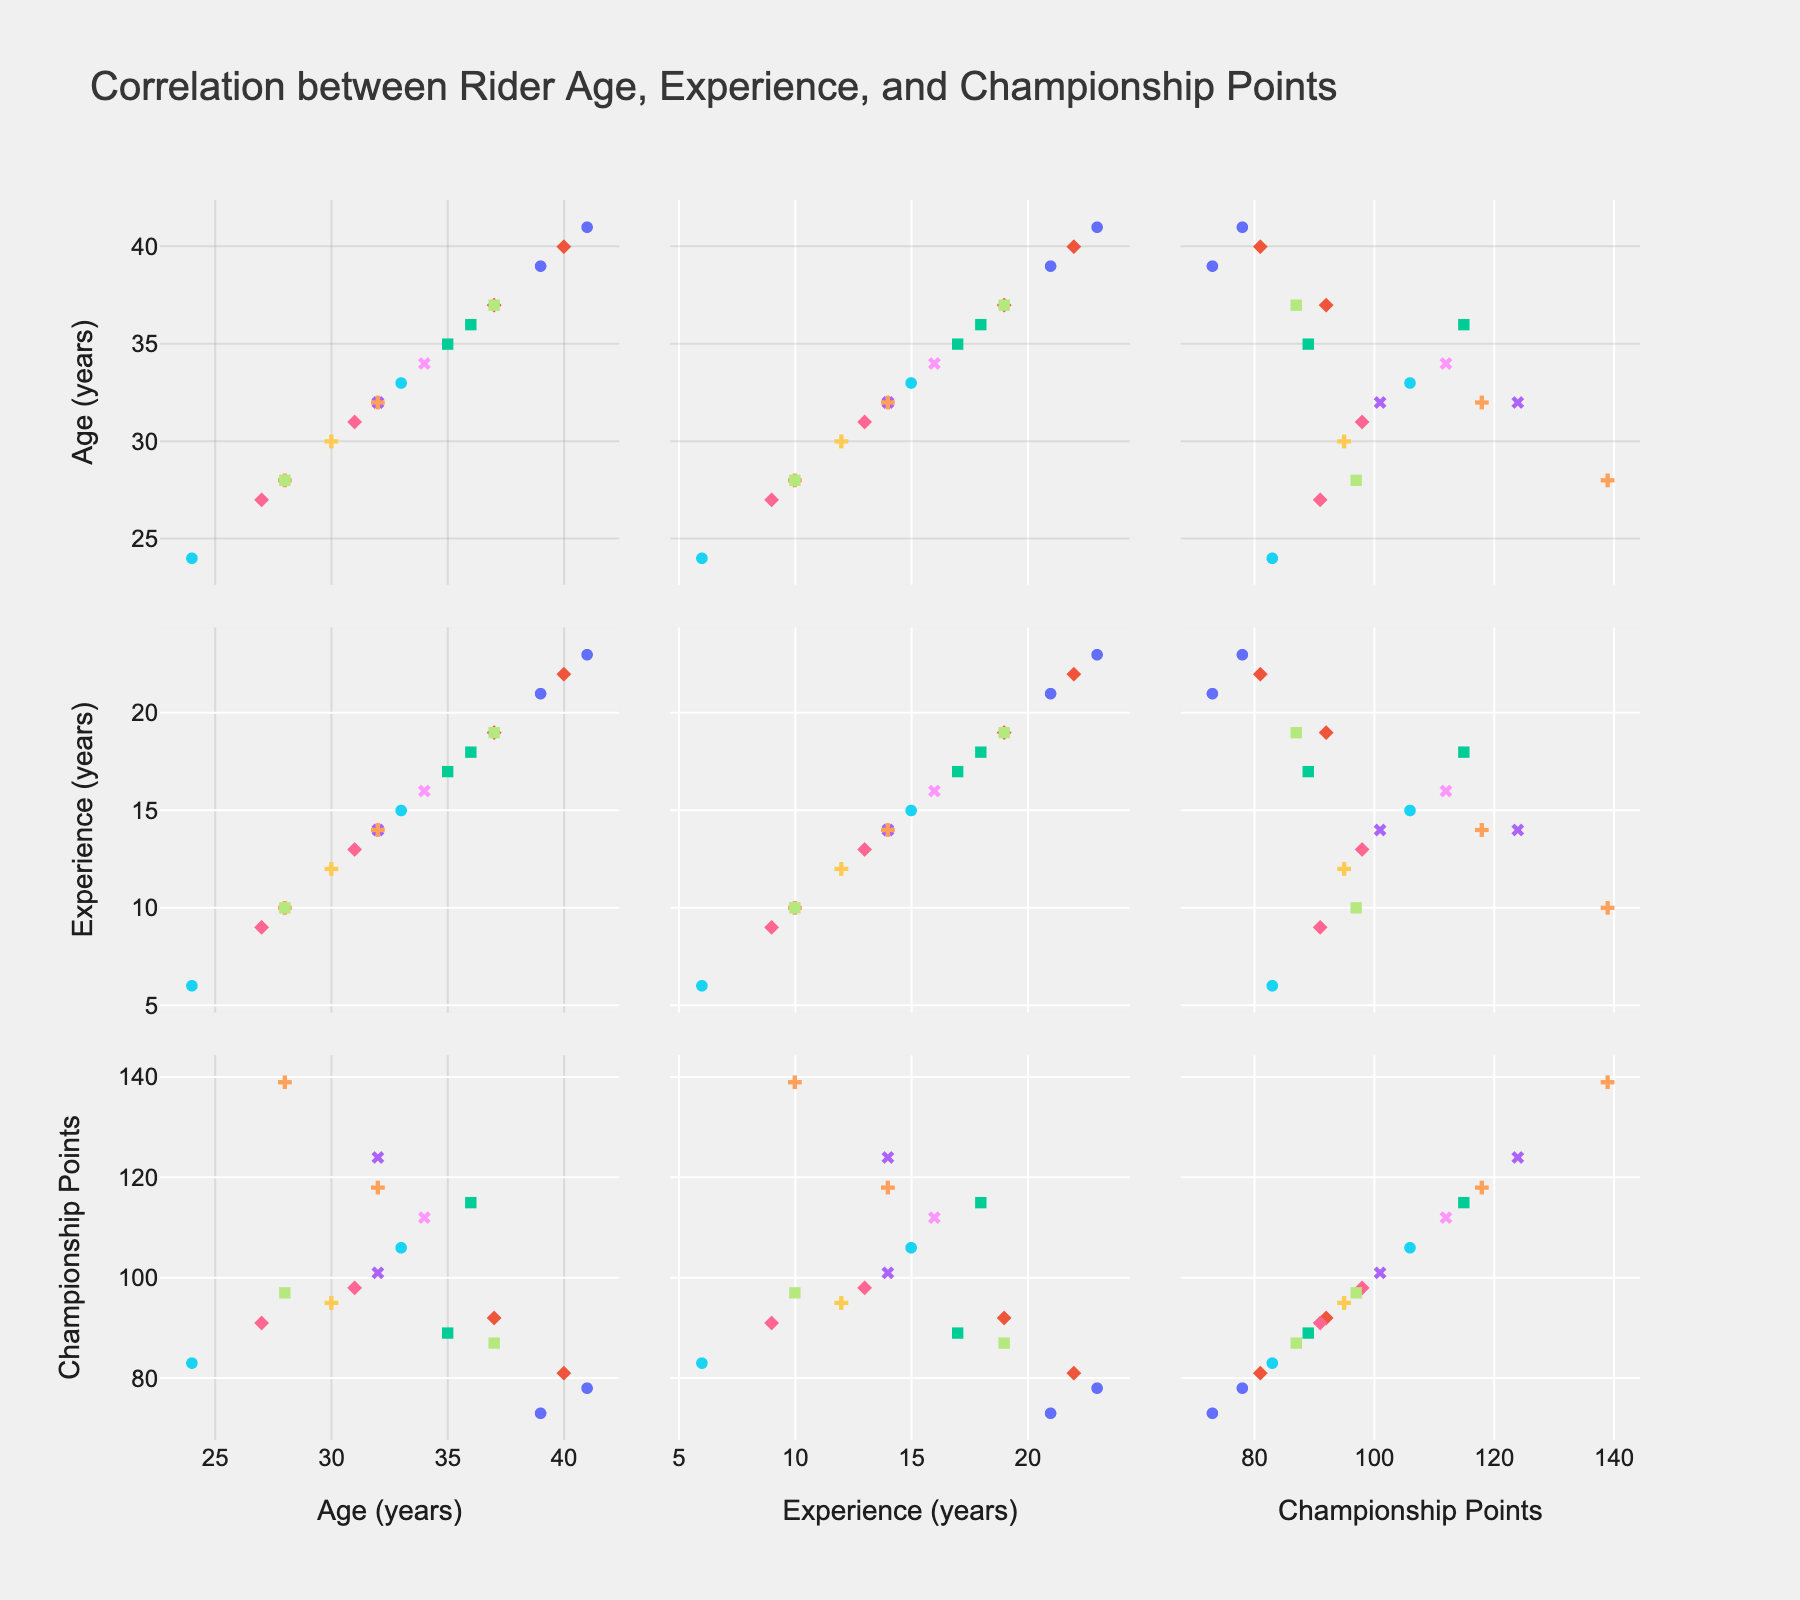What is the title of the scatter plot matrix? The title of a plot is usually displayed at the top. By looking at the top of the figure, the title "Correlation between Rider Age, Experience, and Championship Points" can be observed.
Answer: Correlation between Rider Age, Experience, and Championship Points What are the variables represented in the scatter plot matrix? The variables in the scatter plot matrix are indicated by the axis labels on each scatter plot. The labels include "Age (years)", "Experience (years)", and "Championship Points".
Answer: Age, Experience, Championship Points How many data points are in the scatter plot matrix? Each scatter plot within the matrix contains multiple data points representing individual riders. Counting the number of distinct riders listed under 'Rider' will give the total number of data points, which is 18.
Answer: 18 Which rider has the highest championship points and what is their experience? By identifying the rider with the maximum 'Championship Points' value and cross-referencing their 'Experience' information from the dataset, it can be noted that Bartosz Zmarzlik has the highest championship points (139) and 10 years of experience.
Answer: Bartosz Zmarzlik, 10 years of experience Is there a general trend between rider's age and experience? By observing the scatter plot that compares 'Age' and 'Experience', one can see that as 'Age' increases, 'Experience' also tends to increase, indicating a positive correlation.
Answer: Positive correlation What is the average age of riders with more than 100 championship points? Identify the riders with championship points greater than 100, then find their ages. The ages are 36, 32, 28, 33, 34, and 32. Calculate the average by summing these ages (36 + 32 + 28 + 33 + 34 + 32 = 195) and dividing by the number of riders with more than 100 points (6).
Answer: 32.5 Who is the youngest rider and how many championship points do they have? The youngest rider can be identified by looking for the minimum age in the dataset. This is Robert Lambert (24 years). Next, check Robert Lambert's championship points, which is 83.
Answer: Robert Lambert, 83 points Do more experienced riders always score higher championship points? By examining the scatter plots involving 'Experience' and 'Championship Points', it can be observed that there is not a clear linear trend; some less experienced riders score comparably or even higher than more experienced riders.
Answer: No Which rider has exactly 14 years of experience and what are their championship points? Check the dataset for the rider with 14 years of experience. The riders are Tai Woffinden, Martin Vaculik, and Artem Laguta. Their championship points are 124, 101, and 118 respectively.
Answer: Tai Woffinden, Martin Vaculik, Artem Laguta; 124, 101, 118 points 